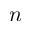Convert formula to latex. <formula><loc_0><loc_0><loc_500><loc_500>n</formula> 